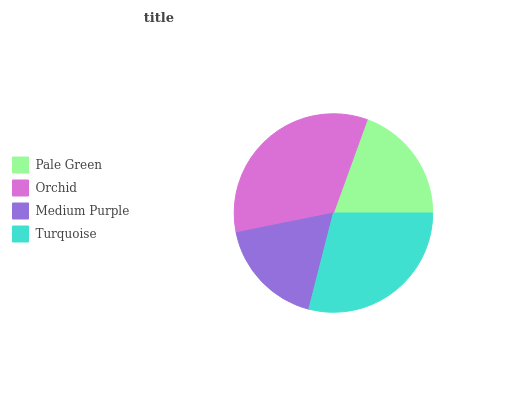Is Medium Purple the minimum?
Answer yes or no. Yes. Is Orchid the maximum?
Answer yes or no. Yes. Is Orchid the minimum?
Answer yes or no. No. Is Medium Purple the maximum?
Answer yes or no. No. Is Orchid greater than Medium Purple?
Answer yes or no. Yes. Is Medium Purple less than Orchid?
Answer yes or no. Yes. Is Medium Purple greater than Orchid?
Answer yes or no. No. Is Orchid less than Medium Purple?
Answer yes or no. No. Is Turquoise the high median?
Answer yes or no. Yes. Is Pale Green the low median?
Answer yes or no. Yes. Is Orchid the high median?
Answer yes or no. No. Is Orchid the low median?
Answer yes or no. No. 